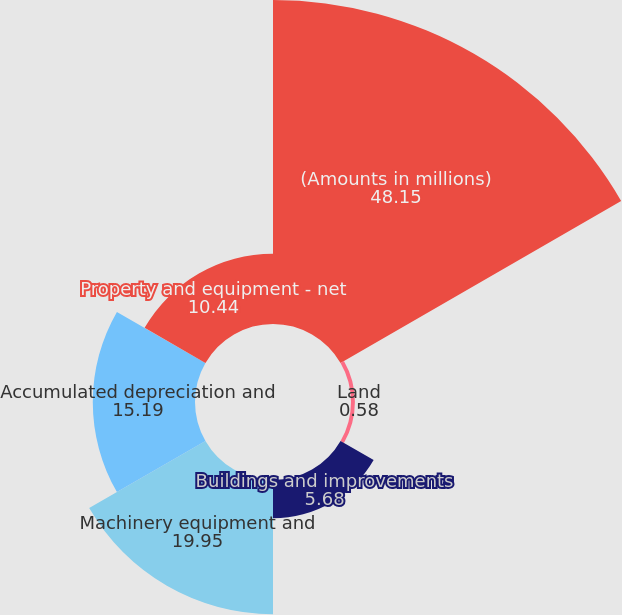Convert chart to OTSL. <chart><loc_0><loc_0><loc_500><loc_500><pie_chart><fcel>(Amounts in millions)<fcel>Land<fcel>Buildings and improvements<fcel>Machinery equipment and<fcel>Accumulated depreciation and<fcel>Property and equipment - net<nl><fcel>48.15%<fcel>0.58%<fcel>5.68%<fcel>19.95%<fcel>15.19%<fcel>10.44%<nl></chart> 